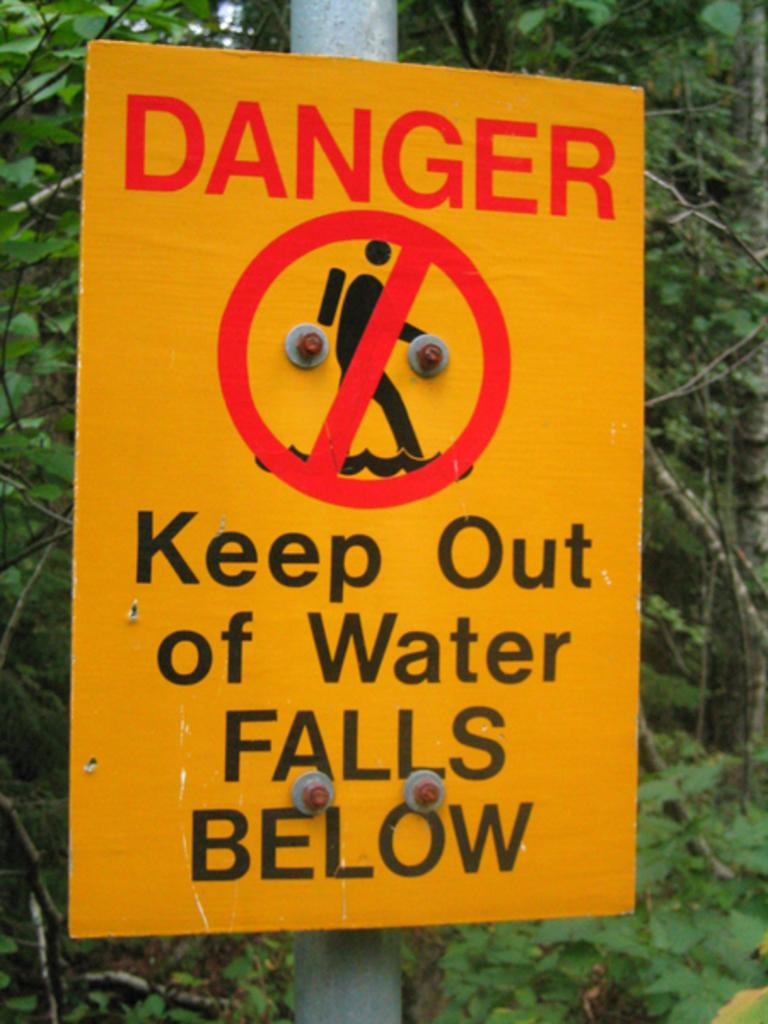What type of sign is visible in the image? There is a danger board in the image. How is the danger board attached to its location? The danger board is fixed to a pole. What can be seen in the background of the image? There are trees in the background of the image. What type of tray is used to serve food on the danger board? There is no tray present in the image, as it features a danger board fixed to a pole with trees in the background. 